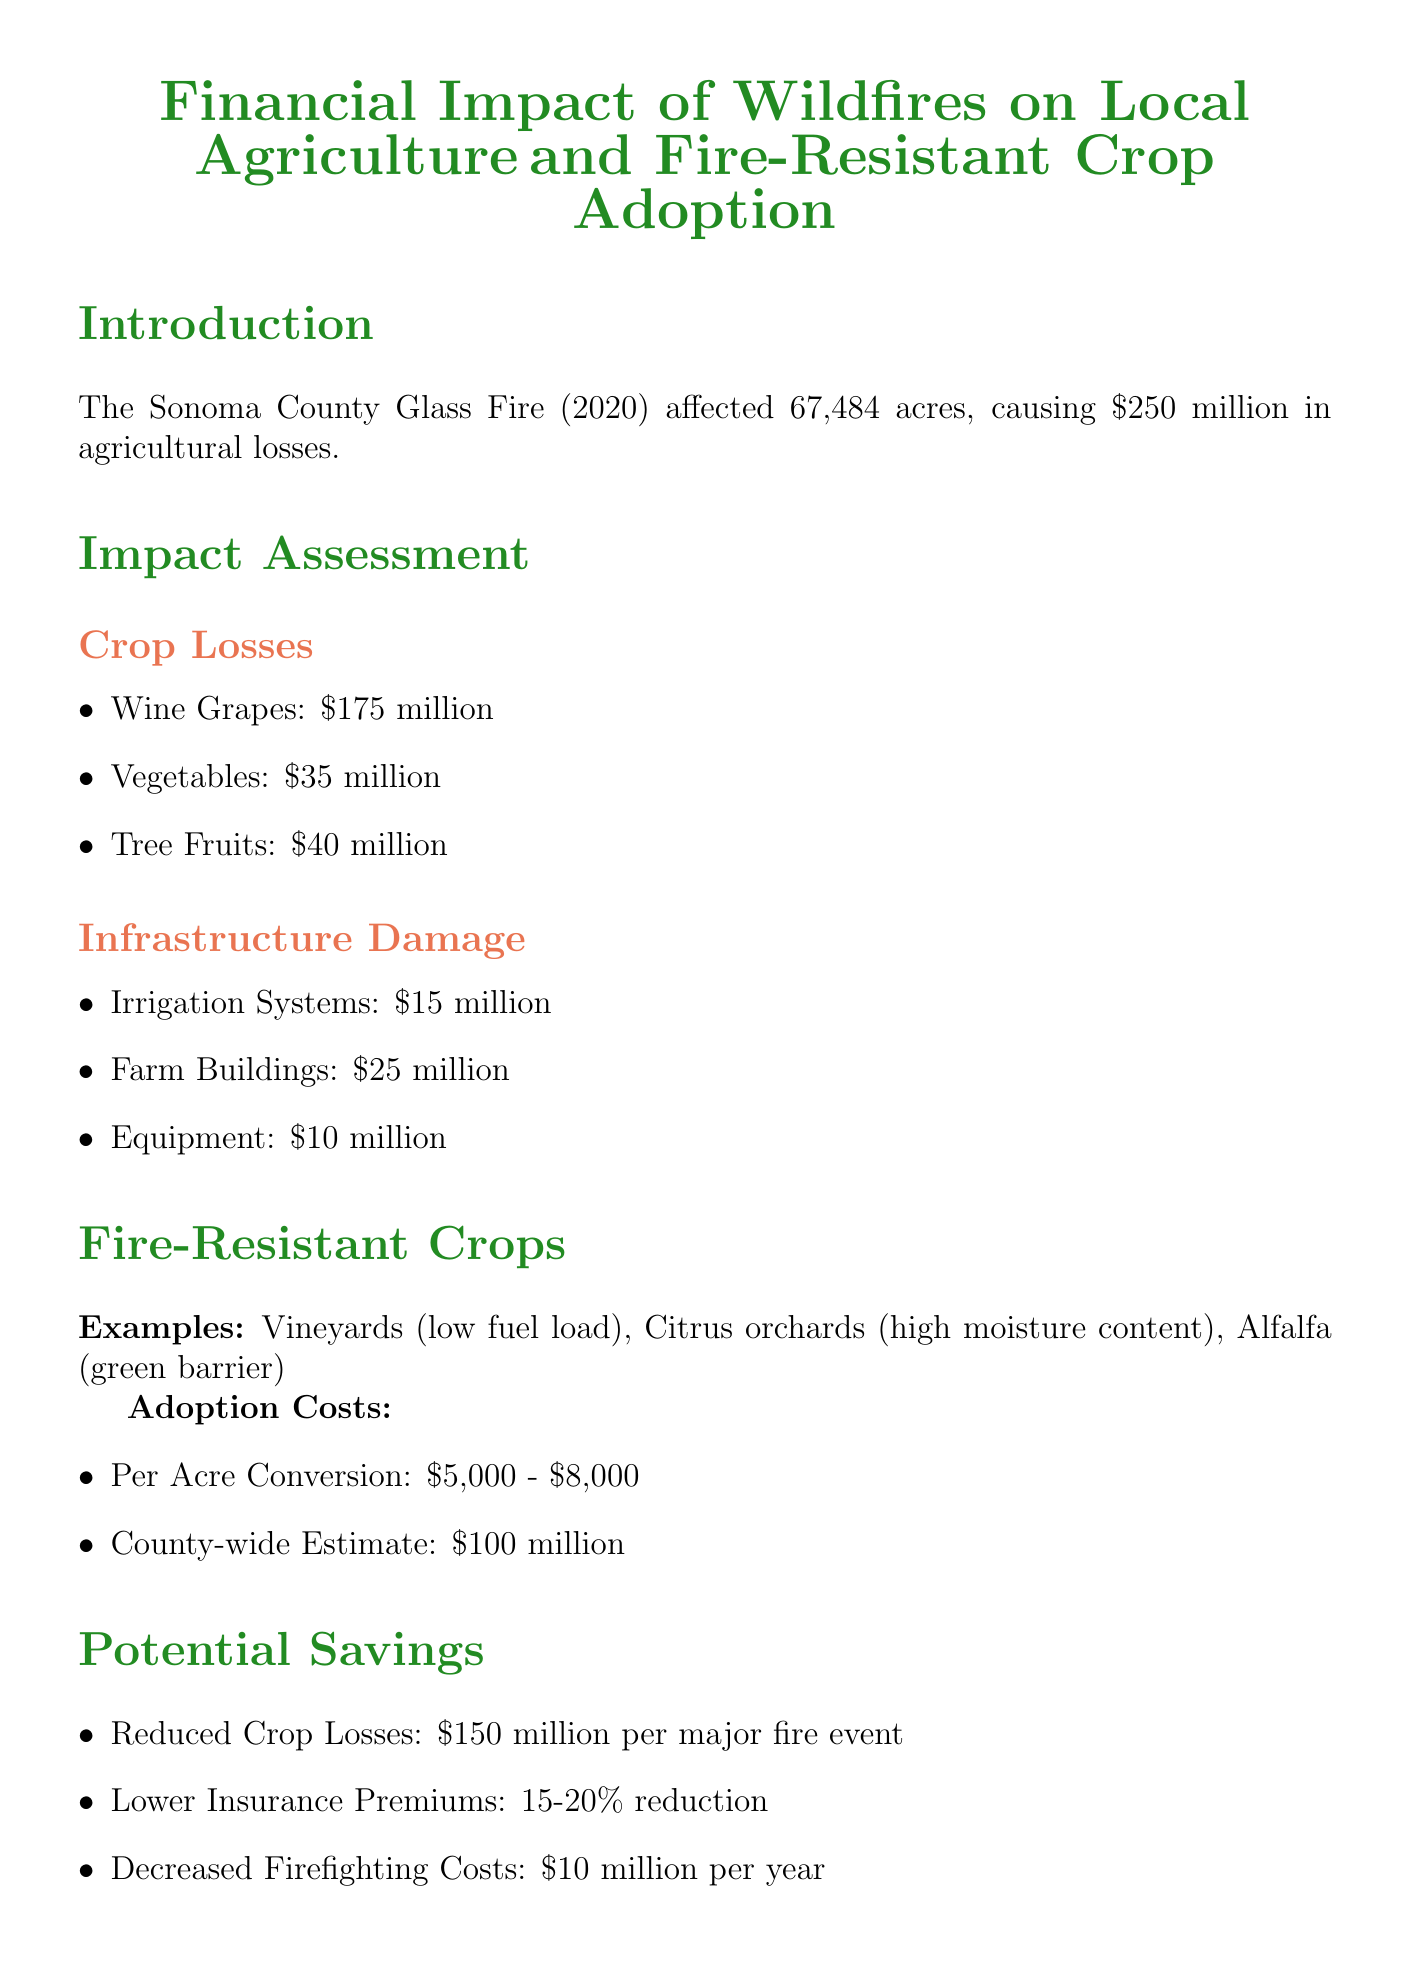What wildfire event is highlighted in the report? The introduction mentions that the Sonoma County Glass Fire (2020) is the highlighted event.
Answer: Sonoma County Glass Fire (2020) What was the total area affected by the recent wildfire? The report states that 67,484 acres were affected by the wildfire.
Answer: 67,484 acres What were the agricultural losses caused by the wildfire? According to the introduction, the total agricultural losses were reported to be $250 million.
Answer: $250 million How much was lost in wine grapes? The impact assessment section provides details that wine grapes lost $175 million due to the wildfire.
Answer: $175 million What are the potential savings from reduced crop losses per major fire event? The document indicates that reduced crop losses can save $150 million per major fire event.
Answer: $150 million What is the estimated ROI for fire-resistant crop adoption? The conclusion states that the ROI estimate for adopting fire-resistant crops is 2-3 years.
Answer: 2-3 years What percentage reduction in insurance premiums is estimated? The report mentions that insurance premiums could see a 15-20% reduction.
Answer: 15-20% What is one example of a fire-resistant crop mentioned? The fire-resistant crops section lists vineyards as an example of a low fuel load crop.
Answer: Vineyards How much is the county-wide estimate for adopting fire-resistant crops? The document states that the county-wide estimate for crop adoption costs is $100 million.
Answer: $100 million 